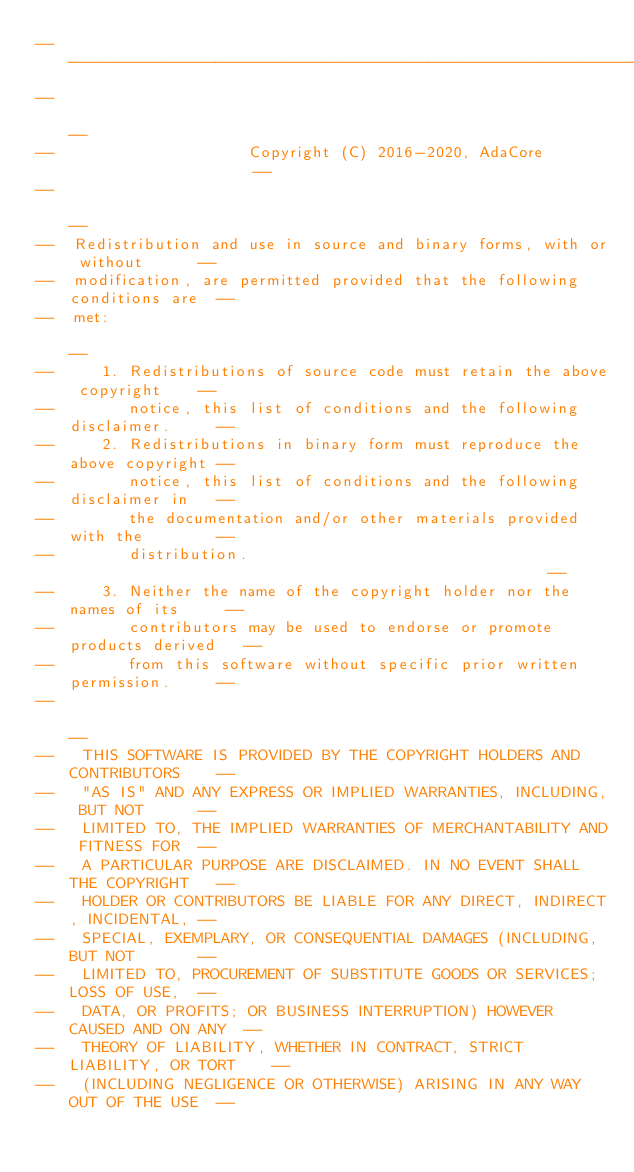<code> <loc_0><loc_0><loc_500><loc_500><_Ada_>------------------------------------------------------------------------------
--                                                                          --
--                     Copyright (C) 2016-2020, AdaCore                     --
--                                                                          --
--  Redistribution and use in source and binary forms, with or without      --
--  modification, are permitted provided that the following conditions are  --
--  met:                                                                    --
--     1. Redistributions of source code must retain the above copyright    --
--        notice, this list of conditions and the following disclaimer.     --
--     2. Redistributions in binary form must reproduce the above copyright --
--        notice, this list of conditions and the following disclaimer in   --
--        the documentation and/or other materials provided with the        --
--        distribution.                                                     --
--     3. Neither the name of the copyright holder nor the names of its     --
--        contributors may be used to endorse or promote products derived   --
--        from this software without specific prior written permission.     --
--                                                                          --
--   THIS SOFTWARE IS PROVIDED BY THE COPYRIGHT HOLDERS AND CONTRIBUTORS    --
--   "AS IS" AND ANY EXPRESS OR IMPLIED WARRANTIES, INCLUDING, BUT NOT      --
--   LIMITED TO, THE IMPLIED WARRANTIES OF MERCHANTABILITY AND FITNESS FOR  --
--   A PARTICULAR PURPOSE ARE DISCLAIMED. IN NO EVENT SHALL THE COPYRIGHT   --
--   HOLDER OR CONTRIBUTORS BE LIABLE FOR ANY DIRECT, INDIRECT, INCIDENTAL, --
--   SPECIAL, EXEMPLARY, OR CONSEQUENTIAL DAMAGES (INCLUDING, BUT NOT       --
--   LIMITED TO, PROCUREMENT OF SUBSTITUTE GOODS OR SERVICES; LOSS OF USE,  --
--   DATA, OR PROFITS; OR BUSINESS INTERRUPTION) HOWEVER CAUSED AND ON ANY  --
--   THEORY OF LIABILITY, WHETHER IN CONTRACT, STRICT LIABILITY, OR TORT    --
--   (INCLUDING NEGLIGENCE OR OTHERWISE) ARISING IN ANY WAY OUT OF THE USE  --</code> 